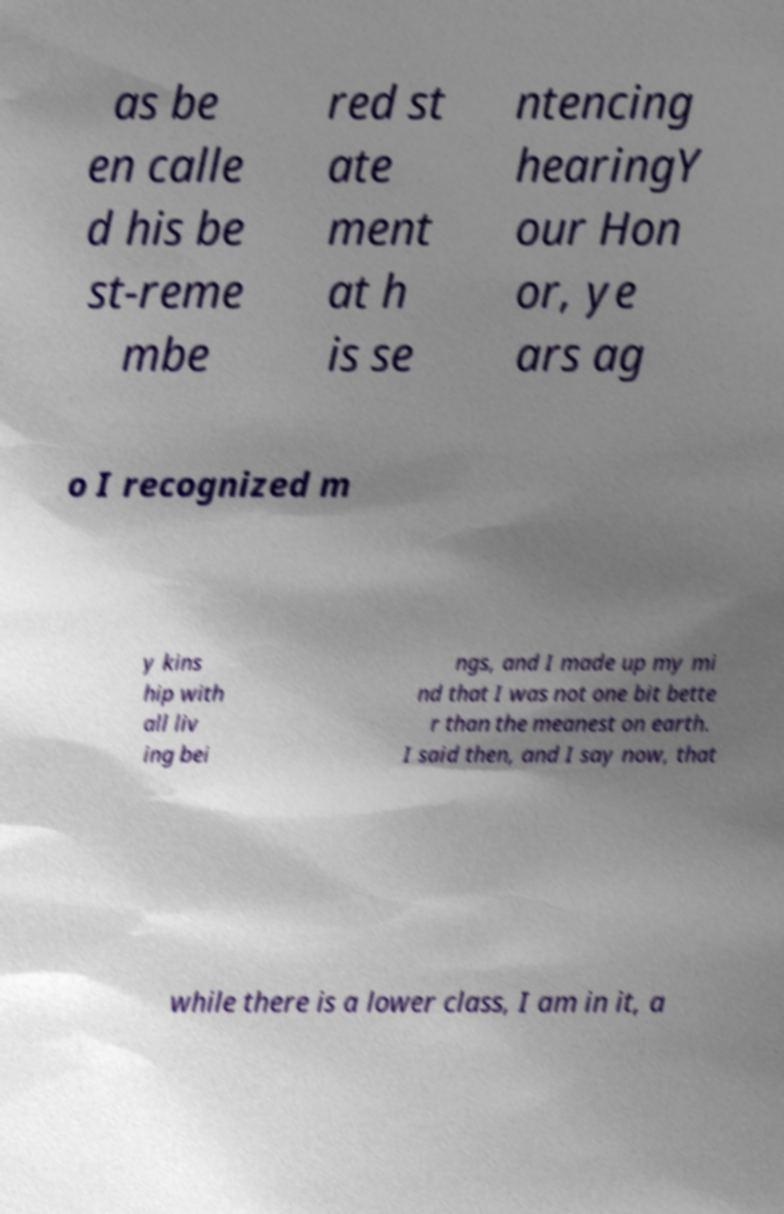Can you accurately transcribe the text from the provided image for me? as be en calle d his be st-reme mbe red st ate ment at h is se ntencing hearingY our Hon or, ye ars ag o I recognized m y kins hip with all liv ing bei ngs, and I made up my mi nd that I was not one bit bette r than the meanest on earth. I said then, and I say now, that while there is a lower class, I am in it, a 